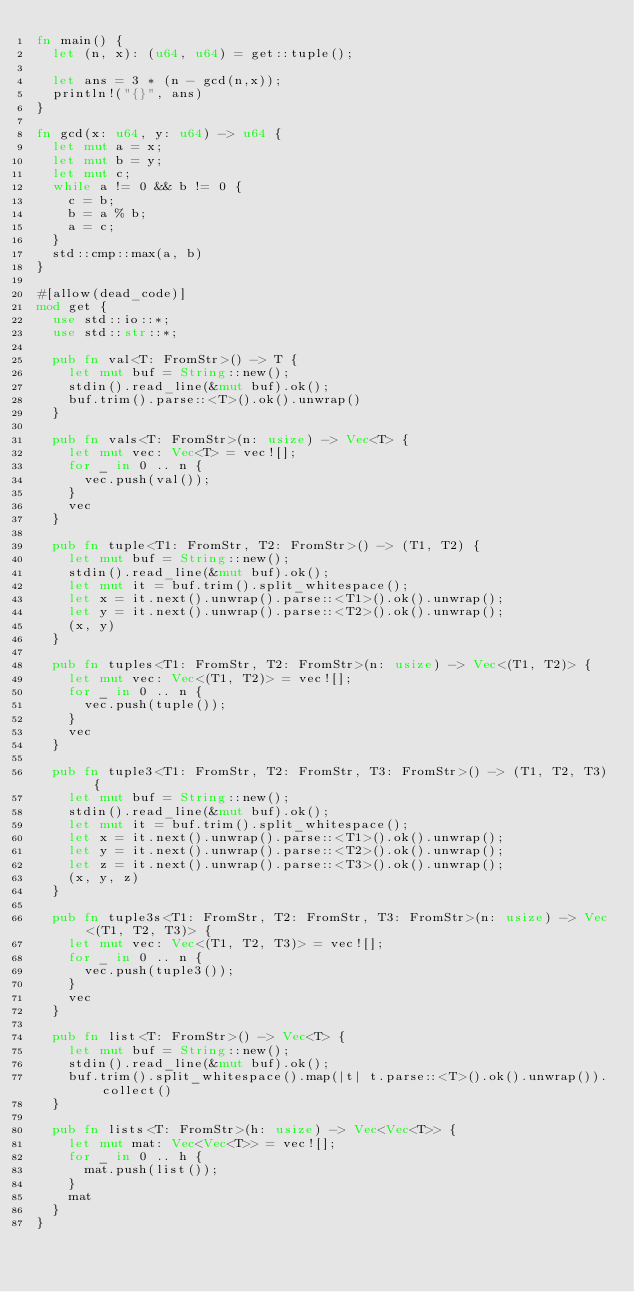Convert code to text. <code><loc_0><loc_0><loc_500><loc_500><_Rust_>fn main() {
  let (n, x): (u64, u64) = get::tuple();

  let ans = 3 * (n - gcd(n,x));
  println!("{}", ans)
}

fn gcd(x: u64, y: u64) -> u64 {
  let mut a = x;
  let mut b = y;
  let mut c;
  while a != 0 && b != 0 {
    c = b;
    b = a % b;
    a = c;
  }
  std::cmp::max(a, b)
}

#[allow(dead_code)]
mod get {
  use std::io::*;
  use std::str::*;

  pub fn val<T: FromStr>() -> T {
    let mut buf = String::new();
    stdin().read_line(&mut buf).ok();
    buf.trim().parse::<T>().ok().unwrap()
  }

  pub fn vals<T: FromStr>(n: usize) -> Vec<T> {
    let mut vec: Vec<T> = vec![];
    for _ in 0 .. n {
      vec.push(val());
    }
    vec
  }

  pub fn tuple<T1: FromStr, T2: FromStr>() -> (T1, T2) {
    let mut buf = String::new();
    stdin().read_line(&mut buf).ok();
    let mut it = buf.trim().split_whitespace();
    let x = it.next().unwrap().parse::<T1>().ok().unwrap();
    let y = it.next().unwrap().parse::<T2>().ok().unwrap();
    (x, y)
  }

  pub fn tuples<T1: FromStr, T2: FromStr>(n: usize) -> Vec<(T1, T2)> {
    let mut vec: Vec<(T1, T2)> = vec![];
    for _ in 0 .. n {
      vec.push(tuple());
    }
    vec
  }

  pub fn tuple3<T1: FromStr, T2: FromStr, T3: FromStr>() -> (T1, T2, T3) {
    let mut buf = String::new();
    stdin().read_line(&mut buf).ok();
    let mut it = buf.trim().split_whitespace();
    let x = it.next().unwrap().parse::<T1>().ok().unwrap();
    let y = it.next().unwrap().parse::<T2>().ok().unwrap();
    let z = it.next().unwrap().parse::<T3>().ok().unwrap();
    (x, y, z)
  }

  pub fn tuple3s<T1: FromStr, T2: FromStr, T3: FromStr>(n: usize) -> Vec<(T1, T2, T3)> {
    let mut vec: Vec<(T1, T2, T3)> = vec![];
    for _ in 0 .. n {
      vec.push(tuple3());
    }
    vec
  }

  pub fn list<T: FromStr>() -> Vec<T> {
    let mut buf = String::new();
    stdin().read_line(&mut buf).ok();
    buf.trim().split_whitespace().map(|t| t.parse::<T>().ok().unwrap()).collect()
  }

  pub fn lists<T: FromStr>(h: usize) -> Vec<Vec<T>> {
    let mut mat: Vec<Vec<T>> = vec![];
    for _ in 0 .. h {
      mat.push(list());
    }
    mat
  }
}
</code> 